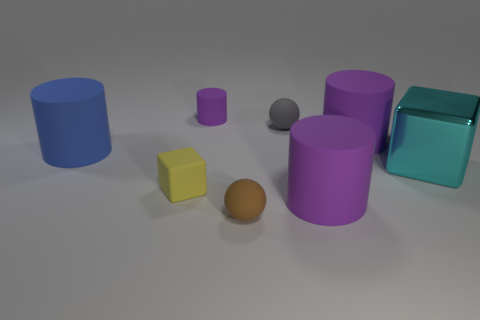Is there anything else that has the same material as the cyan cube?
Your response must be concise. No. Is the number of tiny gray matte objects that are on the left side of the tiny brown matte sphere less than the number of cubes behind the large cyan metal cube?
Offer a very short reply. No. What number of things are matte balls behind the blue cylinder or cyan metal blocks?
Give a very brief answer. 2. There is a tiny thing on the right side of the rubber sphere in front of the big metal object; what shape is it?
Offer a terse response. Sphere. Is there a blue cylinder of the same size as the shiny thing?
Provide a succinct answer. Yes. Is the number of tiny rubber cylinders greater than the number of yellow shiny things?
Provide a short and direct response. Yes. Do the ball that is behind the big cyan shiny object and the purple object that is to the left of the brown object have the same size?
Provide a short and direct response. Yes. How many small rubber things are to the right of the brown sphere and in front of the cyan cube?
Your answer should be compact. 0. What is the color of the other thing that is the same shape as the big cyan object?
Keep it short and to the point. Yellow. Is the number of large blocks less than the number of large purple cylinders?
Give a very brief answer. Yes. 